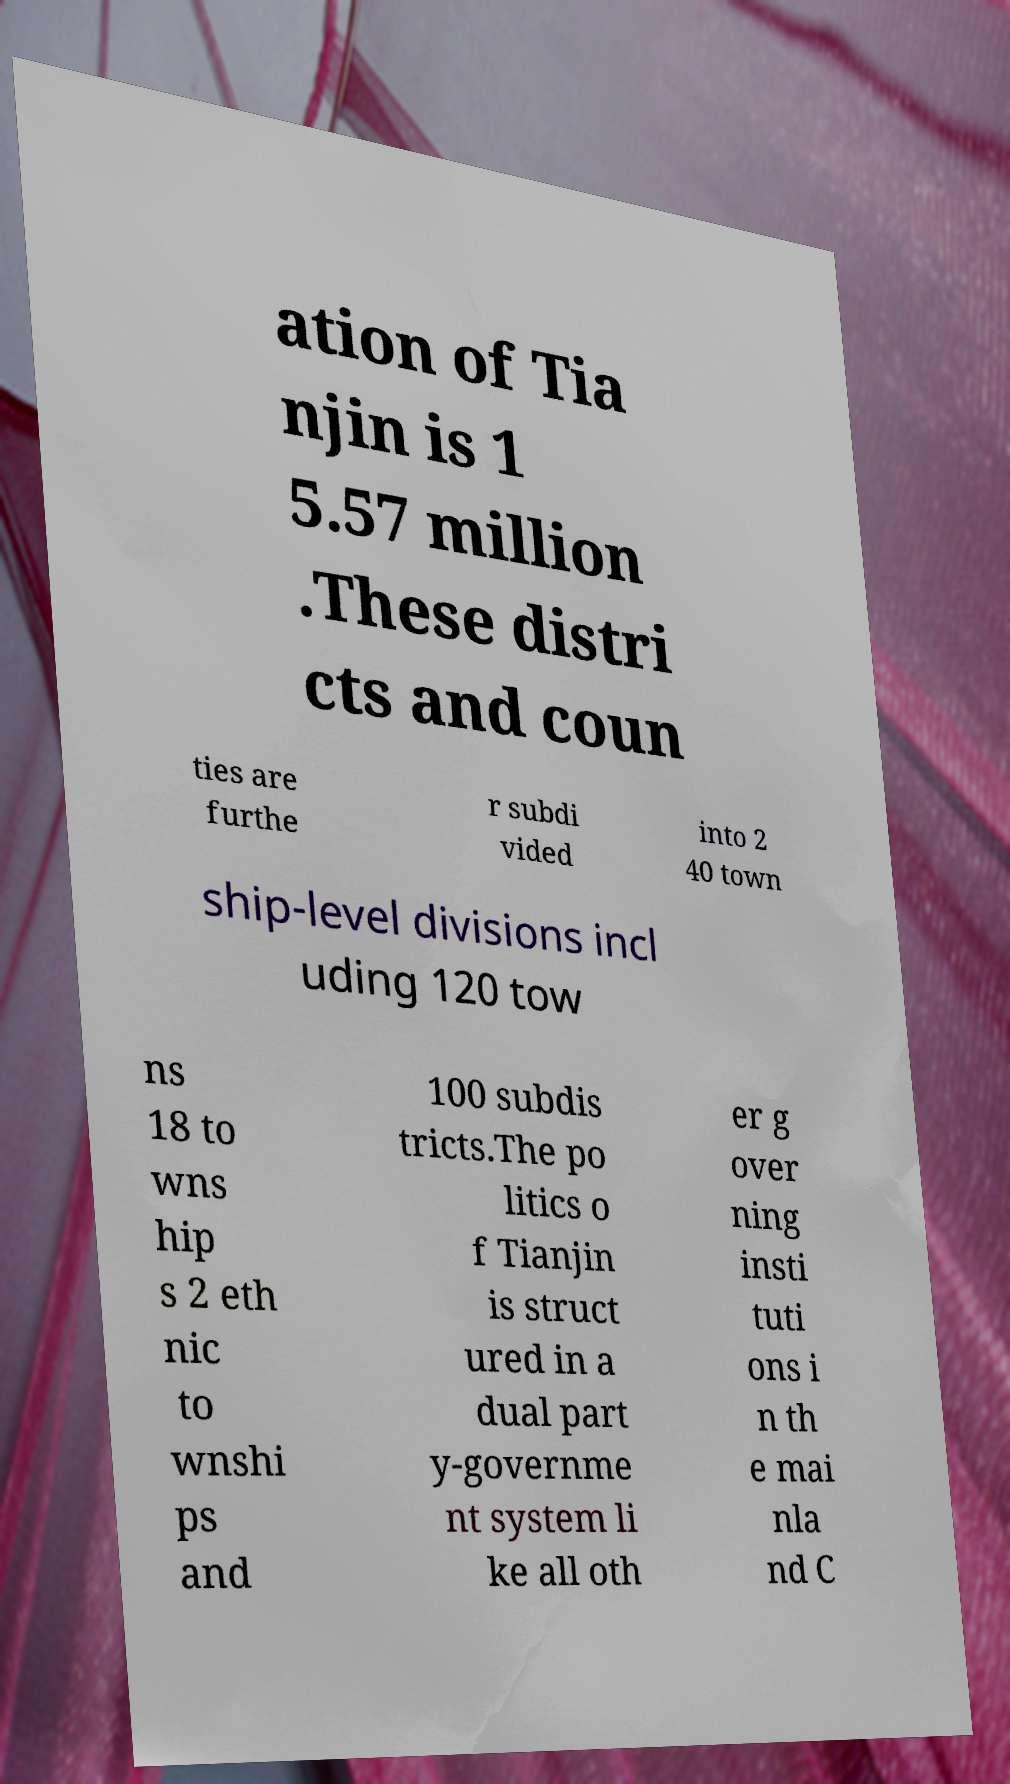Please read and relay the text visible in this image. What does it say? ation of Tia njin is 1 5.57 million .These distri cts and coun ties are furthe r subdi vided into 2 40 town ship-level divisions incl uding 120 tow ns 18 to wns hip s 2 eth nic to wnshi ps and 100 subdis tricts.The po litics o f Tianjin is struct ured in a dual part y-governme nt system li ke all oth er g over ning insti tuti ons i n th e mai nla nd C 